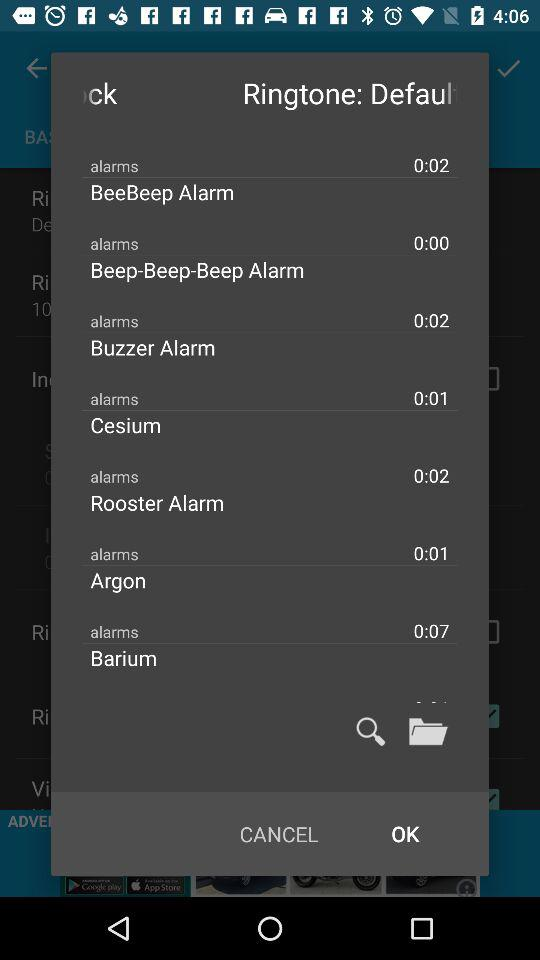How long is the "Cesium" tone? The "Cesium" tone is 0:01 long. 